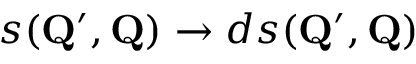<formula> <loc_0><loc_0><loc_500><loc_500>s ( Q ^ { \prime } , Q ) \to d s ( Q ^ { \prime } , Q )</formula> 